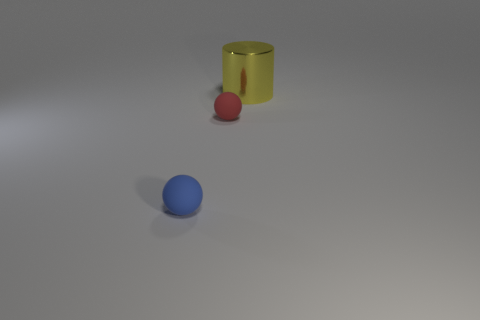There is a ball that is right of the tiny blue matte ball; what size is it?
Your answer should be compact. Small. The other object that is the same material as the small red thing is what shape?
Offer a terse response. Sphere. Does the thing that is to the left of the small red rubber thing have the same material as the red object?
Make the answer very short. Yes. What number of other objects are there of the same material as the small red thing?
Provide a short and direct response. 1. How many things are either things left of the large yellow cylinder or tiny rubber objects in front of the red sphere?
Your answer should be compact. 2. There is a small matte object on the right side of the blue matte thing; does it have the same shape as the object to the right of the red rubber ball?
Provide a short and direct response. No. There is another thing that is the same size as the blue thing; what shape is it?
Your response must be concise. Sphere. What number of matte things are either big purple things or red spheres?
Keep it short and to the point. 1. Are the ball behind the small blue matte ball and the big cylinder that is behind the tiny red matte thing made of the same material?
Your response must be concise. No. What color is the small ball that is the same material as the small red thing?
Offer a very short reply. Blue. 